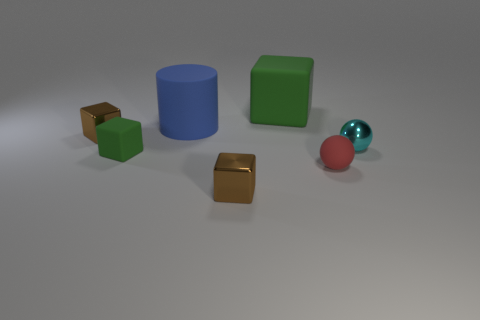Subtract all small rubber cubes. How many cubes are left? 3 Add 2 tiny metal spheres. How many objects exist? 9 Subtract all gray cubes. Subtract all gray cylinders. How many cubes are left? 4 Subtract all spheres. How many objects are left? 5 Subtract all tiny purple shiny objects. Subtract all brown cubes. How many objects are left? 5 Add 4 metallic blocks. How many metallic blocks are left? 6 Add 1 metallic blocks. How many metallic blocks exist? 3 Subtract 0 cyan blocks. How many objects are left? 7 